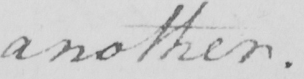Please provide the text content of this handwritten line. another . 